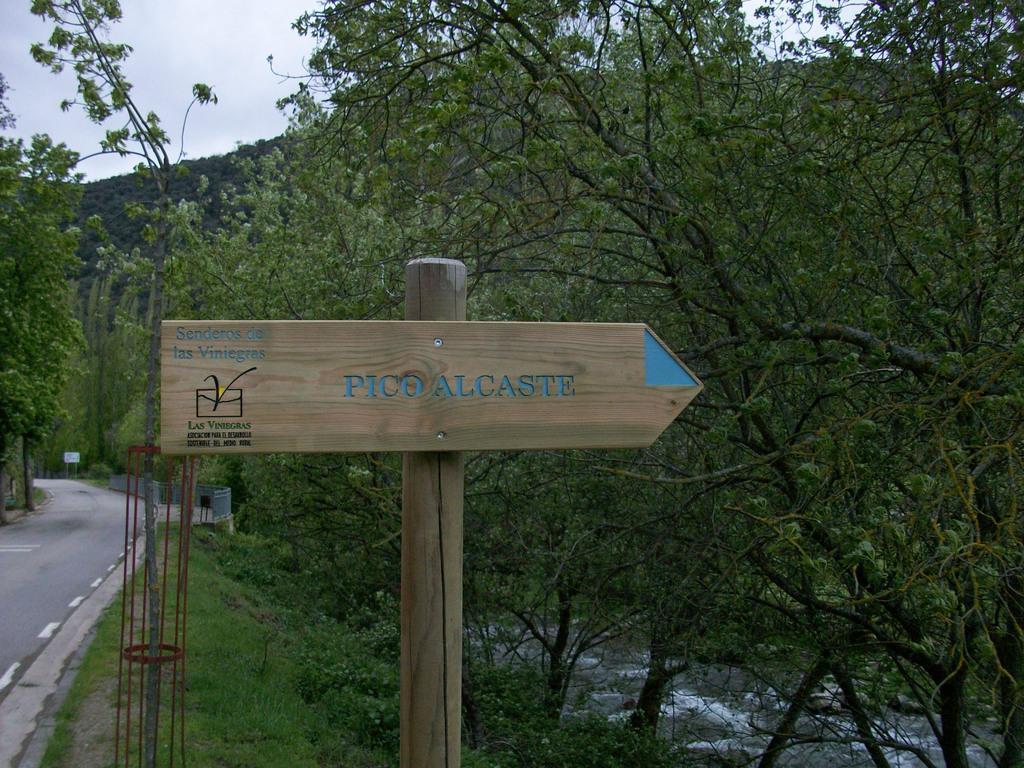In one or two sentences, can you explain what this image depicts? Here there is a road, here there is a board, here there are trees and a sky. 